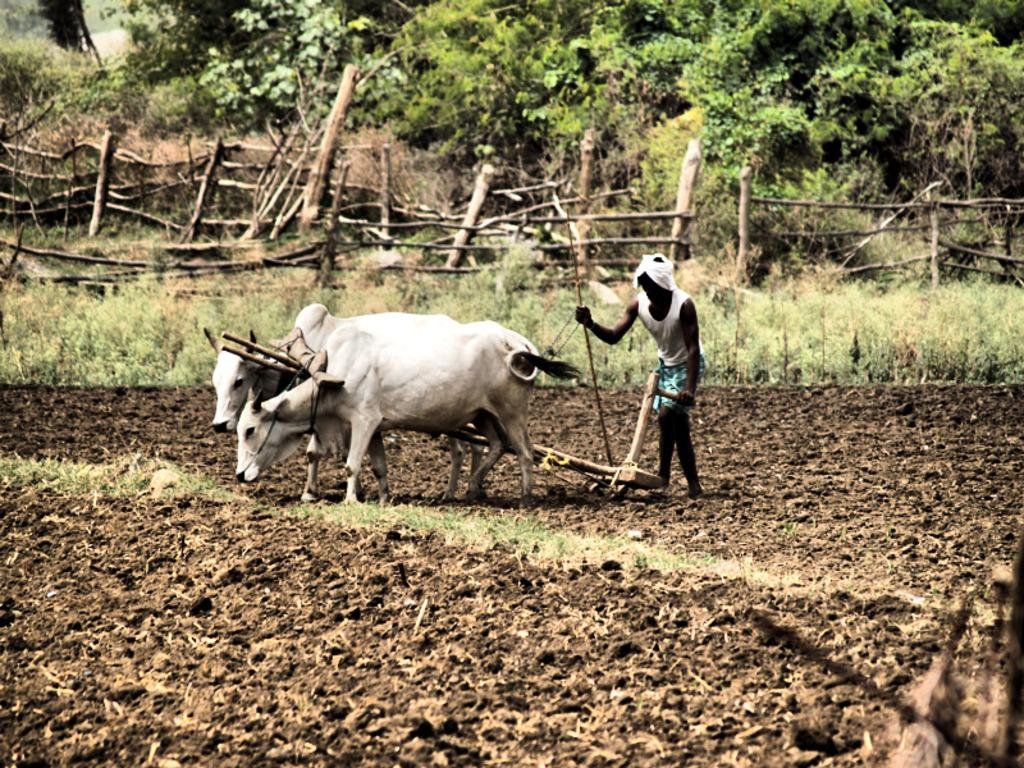What is the person in the image doing? The person in the image is doing farming. What animals are present in the image? Two bulls are present in the image. Where are the bulls located? The bulls are on a ground in the image. What type of fencing can be seen in the image? There is wooden fencing in the image. What type of vegetation is visible at the top of the image? Trees are visible at the top of the image. What type of sea creatures can be seen in the image? There are no sea creatures present in the image; it features a person doing farming and bulls on a ground. How many ants can be seen crawling on the wooden fencing in the image? There are no ants visible in the image; it only features a person, bulls, wooden fencing, and trees. 